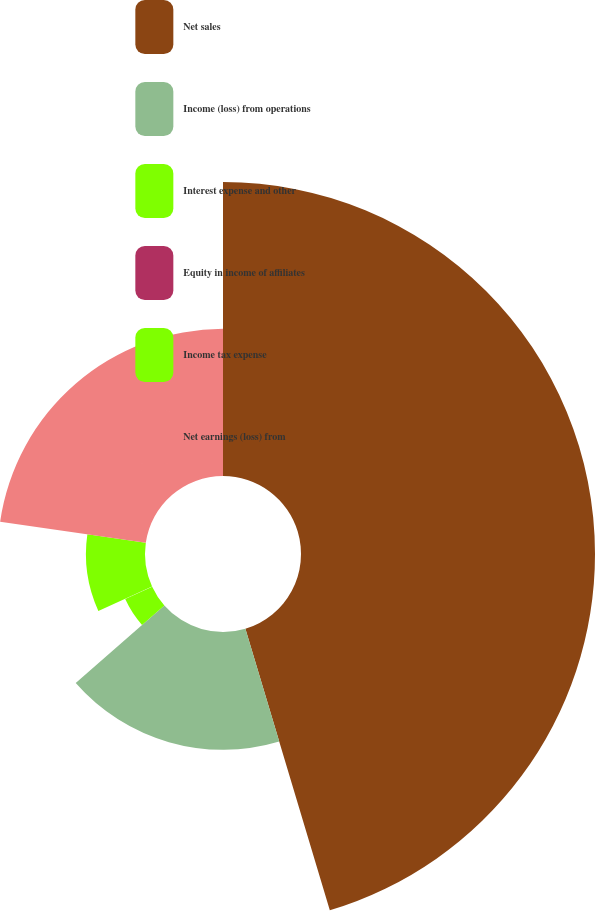<chart> <loc_0><loc_0><loc_500><loc_500><pie_chart><fcel>Net sales<fcel>Income (loss) from operations<fcel>Interest expense and other<fcel>Equity in income of affiliates<fcel>Income tax expense<fcel>Net earnings (loss) from<nl><fcel>45.36%<fcel>18.18%<fcel>4.58%<fcel>0.05%<fcel>9.11%<fcel>22.71%<nl></chart> 